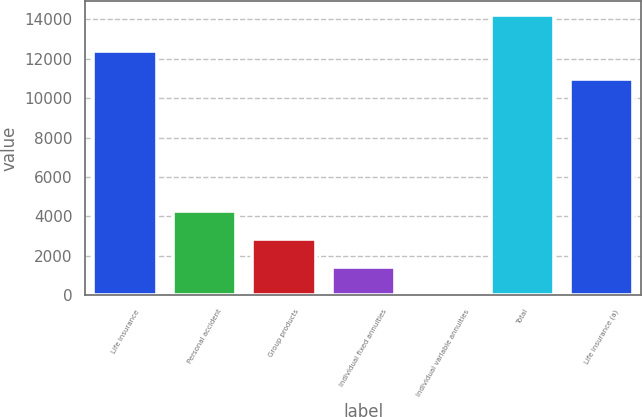Convert chart. <chart><loc_0><loc_0><loc_500><loc_500><bar_chart><fcel>Life insurance<fcel>Personal accident<fcel>Group products<fcel>Individual fixed annuities<fcel>Individual variable annuities<fcel>Total<fcel>Life insurance (a)<nl><fcel>12370.3<fcel>4264.9<fcel>2843.6<fcel>1422.3<fcel>1<fcel>14214<fcel>10949<nl></chart> 